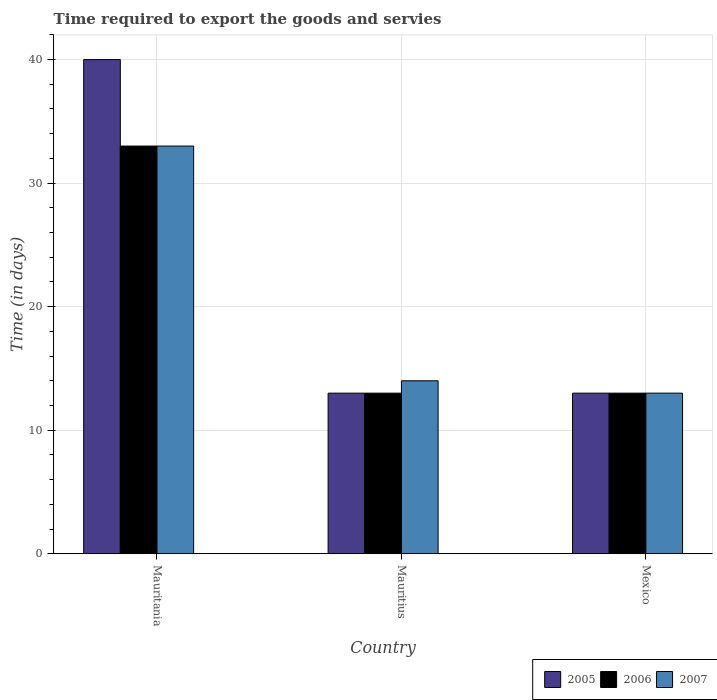How many different coloured bars are there?
Ensure brevity in your answer.  3. Are the number of bars per tick equal to the number of legend labels?
Offer a terse response. Yes. What is the number of days required to export the goods and services in 2005 in Mexico?
Make the answer very short. 13. Across all countries, what is the maximum number of days required to export the goods and services in 2007?
Your response must be concise. 33. Across all countries, what is the minimum number of days required to export the goods and services in 2006?
Offer a very short reply. 13. In which country was the number of days required to export the goods and services in 2005 maximum?
Offer a very short reply. Mauritania. In which country was the number of days required to export the goods and services in 2005 minimum?
Provide a succinct answer. Mauritius. What is the total number of days required to export the goods and services in 2005 in the graph?
Provide a succinct answer. 66. What is the difference between the number of days required to export the goods and services in 2007 in Mauritania and the number of days required to export the goods and services in 2005 in Mexico?
Make the answer very short. 20. What is the average number of days required to export the goods and services in 2006 per country?
Your response must be concise. 19.67. In how many countries, is the number of days required to export the goods and services in 2005 greater than 18 days?
Offer a terse response. 1. What is the ratio of the number of days required to export the goods and services in 2007 in Mauritania to that in Mauritius?
Offer a terse response. 2.36. Is the number of days required to export the goods and services in 2006 in Mauritania less than that in Mauritius?
Ensure brevity in your answer.  No. In how many countries, is the number of days required to export the goods and services in 2006 greater than the average number of days required to export the goods and services in 2006 taken over all countries?
Provide a succinct answer. 1. Is the sum of the number of days required to export the goods and services in 2005 in Mauritius and Mexico greater than the maximum number of days required to export the goods and services in 2006 across all countries?
Offer a very short reply. No. What does the 2nd bar from the left in Mauritius represents?
Your answer should be very brief. 2006. Is it the case that in every country, the sum of the number of days required to export the goods and services in 2005 and number of days required to export the goods and services in 2007 is greater than the number of days required to export the goods and services in 2006?
Your answer should be compact. Yes. Are all the bars in the graph horizontal?
Your response must be concise. No. What is the difference between two consecutive major ticks on the Y-axis?
Your answer should be compact. 10. Are the values on the major ticks of Y-axis written in scientific E-notation?
Keep it short and to the point. No. Does the graph contain any zero values?
Offer a very short reply. No. Does the graph contain grids?
Your answer should be very brief. Yes. What is the title of the graph?
Your answer should be compact. Time required to export the goods and servies. What is the label or title of the Y-axis?
Provide a succinct answer. Time (in days). What is the Time (in days) of 2005 in Mauritania?
Ensure brevity in your answer.  40. What is the Time (in days) in 2007 in Mauritania?
Give a very brief answer. 33. What is the Time (in days) of 2005 in Mauritius?
Provide a succinct answer. 13. What is the Time (in days) in 2006 in Mexico?
Offer a terse response. 13. What is the Time (in days) in 2007 in Mexico?
Offer a very short reply. 13. Across all countries, what is the maximum Time (in days) of 2005?
Your answer should be very brief. 40. Across all countries, what is the maximum Time (in days) in 2007?
Ensure brevity in your answer.  33. Across all countries, what is the minimum Time (in days) of 2006?
Make the answer very short. 13. What is the total Time (in days) in 2006 in the graph?
Your answer should be very brief. 59. What is the difference between the Time (in days) in 2007 in Mauritania and that in Mauritius?
Provide a succinct answer. 19. What is the difference between the Time (in days) of 2005 in Mauritania and that in Mexico?
Ensure brevity in your answer.  27. What is the difference between the Time (in days) in 2007 in Mauritius and that in Mexico?
Ensure brevity in your answer.  1. What is the difference between the Time (in days) in 2005 in Mauritania and the Time (in days) in 2007 in Mauritius?
Offer a terse response. 26. What is the difference between the Time (in days) of 2005 in Mauritania and the Time (in days) of 2006 in Mexico?
Offer a terse response. 27. What is the difference between the Time (in days) of 2005 in Mauritius and the Time (in days) of 2006 in Mexico?
Give a very brief answer. 0. What is the average Time (in days) of 2006 per country?
Your response must be concise. 19.67. What is the average Time (in days) of 2007 per country?
Your answer should be compact. 20. What is the difference between the Time (in days) of 2005 and Time (in days) of 2006 in Mauritania?
Make the answer very short. 7. What is the difference between the Time (in days) in 2005 and Time (in days) in 2007 in Mauritania?
Your response must be concise. 7. What is the difference between the Time (in days) in 2006 and Time (in days) in 2007 in Mauritania?
Your answer should be very brief. 0. What is the difference between the Time (in days) of 2005 and Time (in days) of 2006 in Mauritius?
Your response must be concise. 0. What is the difference between the Time (in days) of 2005 and Time (in days) of 2007 in Mauritius?
Ensure brevity in your answer.  -1. What is the difference between the Time (in days) in 2005 and Time (in days) in 2006 in Mexico?
Your response must be concise. 0. What is the difference between the Time (in days) of 2006 and Time (in days) of 2007 in Mexico?
Offer a very short reply. 0. What is the ratio of the Time (in days) of 2005 in Mauritania to that in Mauritius?
Keep it short and to the point. 3.08. What is the ratio of the Time (in days) of 2006 in Mauritania to that in Mauritius?
Keep it short and to the point. 2.54. What is the ratio of the Time (in days) of 2007 in Mauritania to that in Mauritius?
Offer a terse response. 2.36. What is the ratio of the Time (in days) of 2005 in Mauritania to that in Mexico?
Offer a terse response. 3.08. What is the ratio of the Time (in days) of 2006 in Mauritania to that in Mexico?
Give a very brief answer. 2.54. What is the ratio of the Time (in days) in 2007 in Mauritania to that in Mexico?
Your response must be concise. 2.54. What is the ratio of the Time (in days) of 2006 in Mauritius to that in Mexico?
Your response must be concise. 1. What is the ratio of the Time (in days) of 2007 in Mauritius to that in Mexico?
Your answer should be very brief. 1.08. What is the difference between the highest and the second highest Time (in days) of 2005?
Your response must be concise. 27. What is the difference between the highest and the second highest Time (in days) in 2007?
Give a very brief answer. 19. What is the difference between the highest and the lowest Time (in days) in 2005?
Offer a very short reply. 27. What is the difference between the highest and the lowest Time (in days) in 2006?
Your response must be concise. 20. 